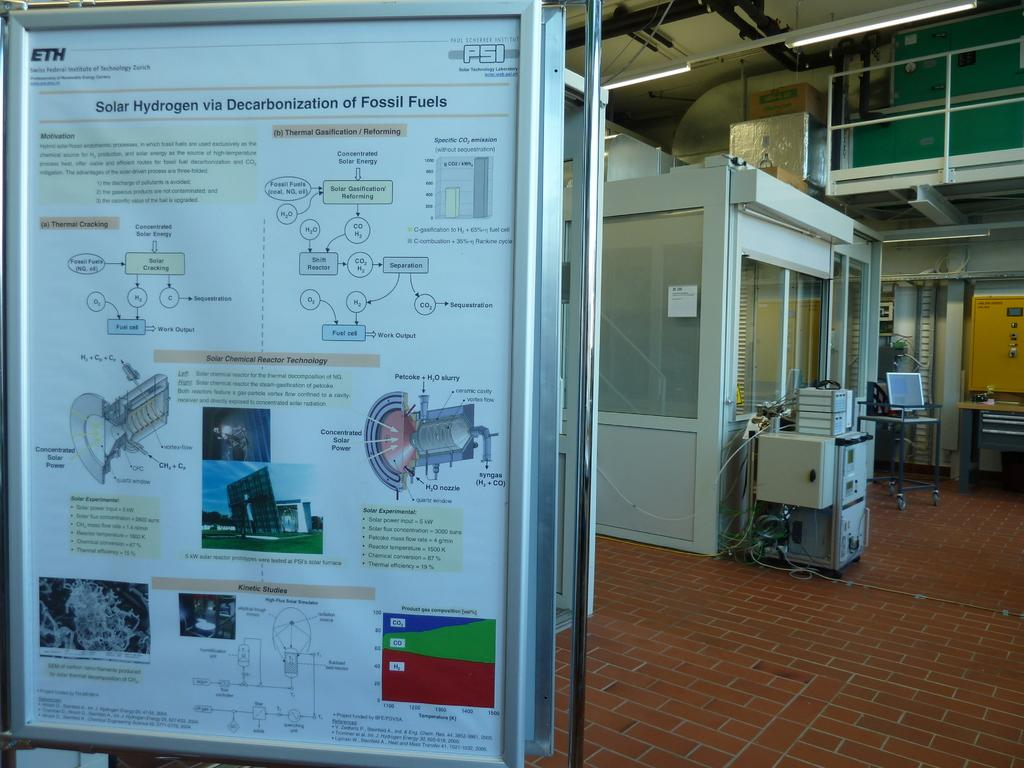<image>
Relay a brief, clear account of the picture shown. A scientific poster explains the concept and process behind Solar Hydrogen. 